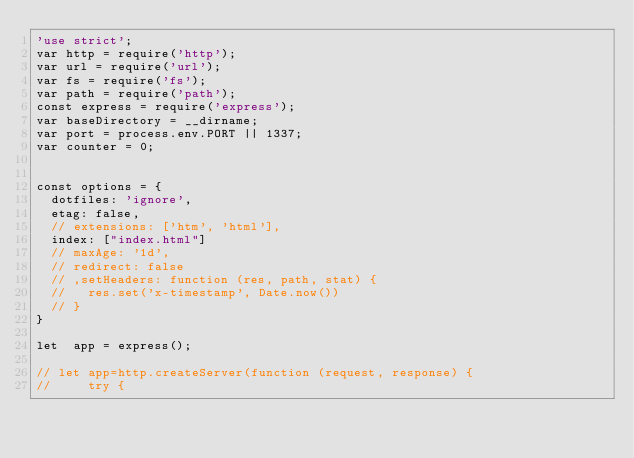Convert code to text. <code><loc_0><loc_0><loc_500><loc_500><_JavaScript_>'use strict';
var http = require('http');
var url = require('url');
var fs = require('fs');
var path = require('path');
const express = require('express');
var baseDirectory = __dirname;
var port = process.env.PORT || 1337;
var counter = 0;


const options = {
  dotfiles: 'ignore',
  etag: false,
  // extensions: ['htm', 'html'],
  index: ["index.html"]
  // maxAge: '1d',
  // redirect: false
  // ,setHeaders: function (res, path, stat) {
  //   res.set('x-timestamp', Date.now())
  // }
}

let  app = express();

// let app=http.createServer(function (request, response) {
//     try {</code> 